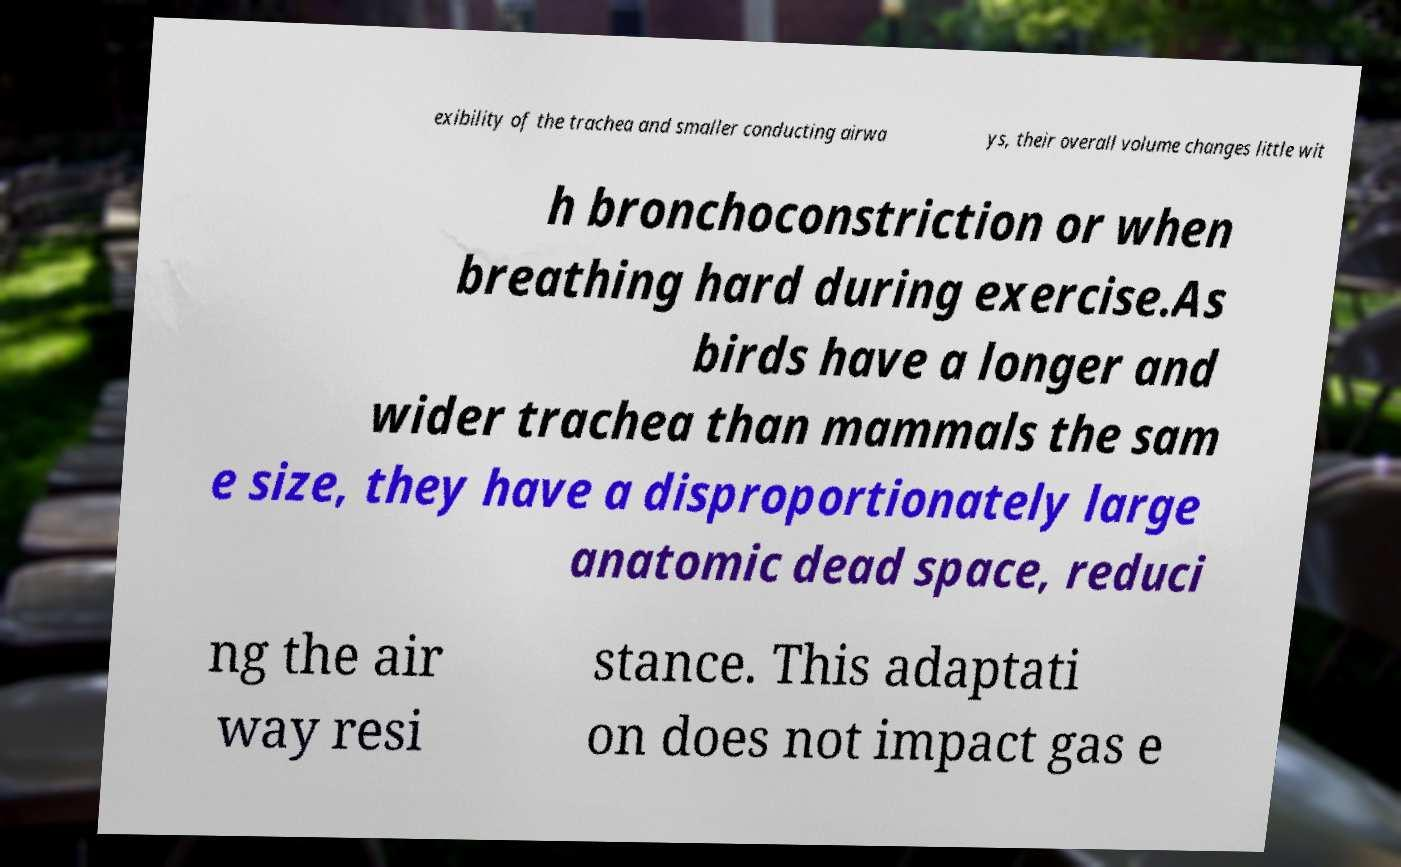I need the written content from this picture converted into text. Can you do that? exibility of the trachea and smaller conducting airwa ys, their overall volume changes little wit h bronchoconstriction or when breathing hard during exercise.As birds have a longer and wider trachea than mammals the sam e size, they have a disproportionately large anatomic dead space, reduci ng the air way resi stance. This adaptati on does not impact gas e 